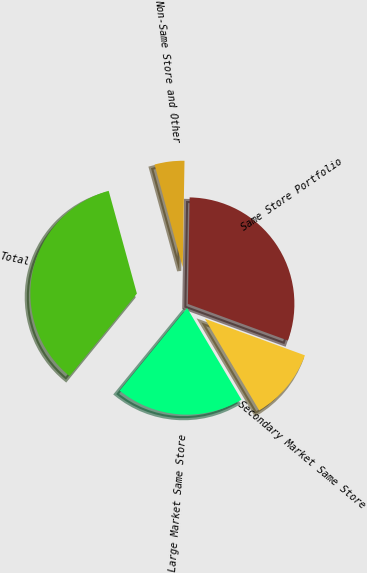Convert chart. <chart><loc_0><loc_0><loc_500><loc_500><pie_chart><fcel>Large Market Same Store<fcel>Secondary Market Same Store<fcel>Same Store Portfolio<fcel>Non-Same Store and Other<fcel>Total<nl><fcel>19.42%<fcel>10.9%<fcel>30.32%<fcel>4.53%<fcel>34.84%<nl></chart> 